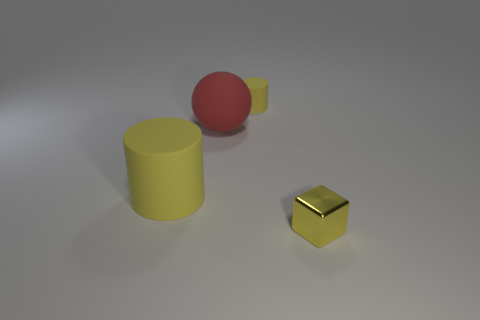Are there any yellow metallic cubes left of the red matte thing?
Your answer should be very brief. No. There is a yellow rubber cylinder that is left of the large matte sphere; is there a big thing that is right of it?
Ensure brevity in your answer.  Yes. Is the number of yellow rubber objects that are to the left of the red matte thing the same as the number of small rubber things in front of the large rubber cylinder?
Offer a very short reply. No. The tiny cylinder that is made of the same material as the big red sphere is what color?
Keep it short and to the point. Yellow. Are there any large cylinders that have the same material as the red thing?
Offer a terse response. Yes. How many objects are either tiny blue matte balls or tiny objects?
Provide a succinct answer. 2. Is the ball made of the same material as the small yellow thing in front of the large yellow matte cylinder?
Ensure brevity in your answer.  No. What size is the yellow object that is behind the large red object?
Your answer should be compact. Small. Are there fewer big matte things than yellow things?
Give a very brief answer. Yes. Are there any large rubber cylinders of the same color as the tiny cylinder?
Offer a terse response. Yes. 